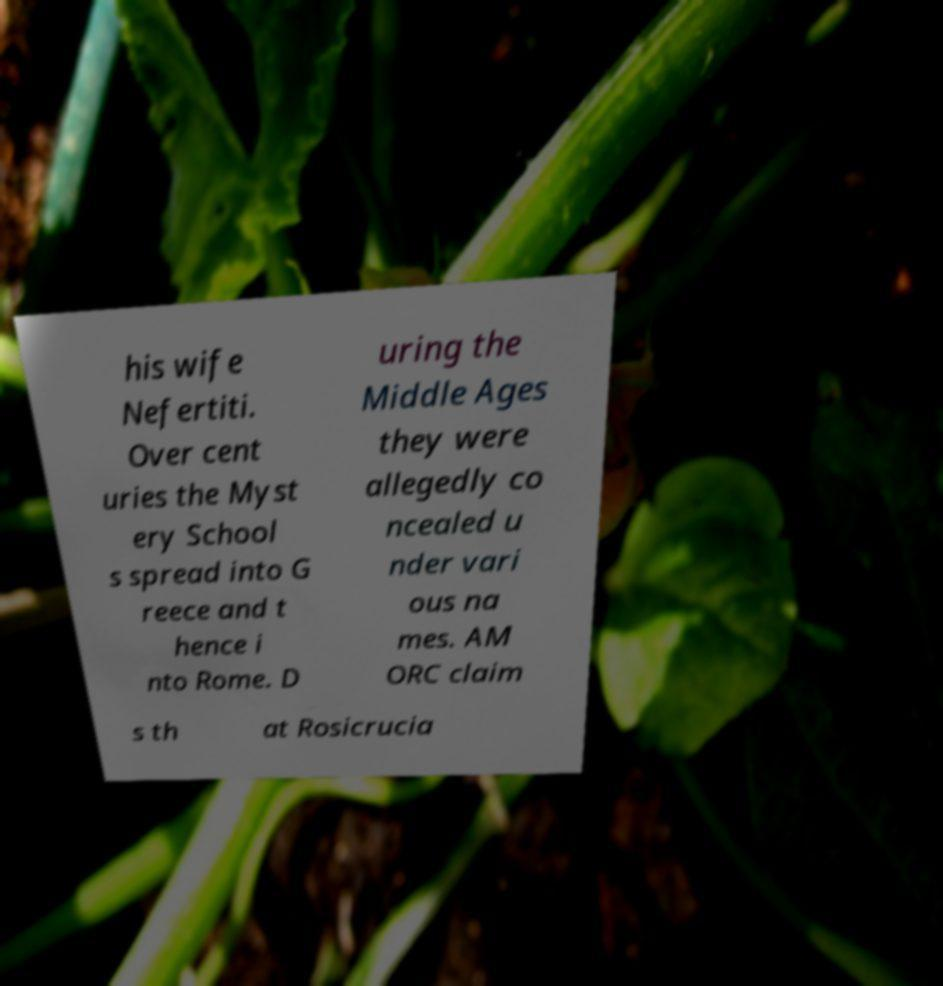Please identify and transcribe the text found in this image. his wife Nefertiti. Over cent uries the Myst ery School s spread into G reece and t hence i nto Rome. D uring the Middle Ages they were allegedly co ncealed u nder vari ous na mes. AM ORC claim s th at Rosicrucia 